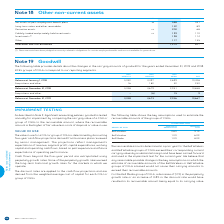According to Bce's financial document, How is goodwill tested annually for impairment? by comparing the carrying value of a CGU or group of CGUs to the recoverable amount, where the recoverable amount is the higher of fair value less costs of disposal or value in use. The document states: "cies , goodwill is tested annually for impairment by comparing the carrying value of a CGU or group of CGUs to the recoverable amount, where the recov..." Also, What do the five-year cash flow projections derived from business plans reflect? management’s expectations of revenue, segment profit, capital expenditures, working capital and operating cash flows, based on past experience and future expectations of operating performance. The document states: "wed by senior management. The projections reflect management’s expectations of revenue, segment profit, capital expenditures, working capital and oper..." Also, What is the percentage for Bell Wireless when discount rate assumption is used? According to the financial document, 9.1%. The relevant text states: "Bell Wireless 0.8% 9.1%..." Also, How many components are there under the groups of CGUs? Counting the relevant items in the document: Bell Wireless, Bell Wireline, Bell Media, I find 3 instances. The key data points involved are: Bell Media, Bell Wireless, Bell Wireline. Also, can you calculate: What is the difference in the perpetuity growth rate between Bell Wireless and Bell Wireline? Based on the calculation: 1.0%-0.8%, the result is 0.2 (percentage). This is based on the information: "Bell Wireline 1.0% 6.0% Bell Wireless 0.8% 9.1%..." The key data points involved are: 0.8, 1.0. Also, can you calculate: What is the difference in the discount rate between Bell Wireline and Bell Media? Based on the calculation: 8.0%-6.0%, the result is 2 (percentage). This is based on the information: "Bell Media 1.0% 8.0% Bell Wireline 1.0% 6.0%..." The key data points involved are: 6.0, 8.0. 